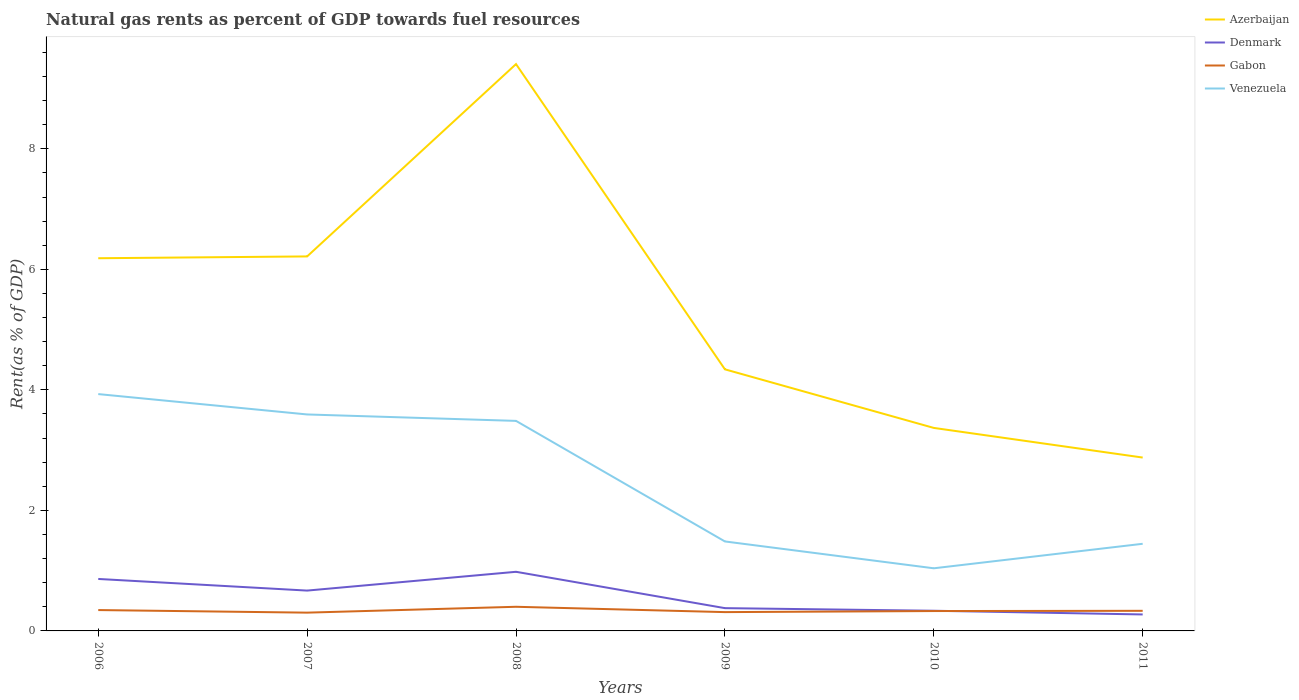How many different coloured lines are there?
Ensure brevity in your answer.  4. Is the number of lines equal to the number of legend labels?
Ensure brevity in your answer.  Yes. Across all years, what is the maximum matural gas rent in Gabon?
Provide a short and direct response. 0.3. What is the total matural gas rent in Gabon in the graph?
Provide a short and direct response. 0.02. What is the difference between the highest and the second highest matural gas rent in Venezuela?
Make the answer very short. 2.89. What is the difference between the highest and the lowest matural gas rent in Gabon?
Offer a terse response. 2. How many lines are there?
Make the answer very short. 4. What is the difference between two consecutive major ticks on the Y-axis?
Offer a very short reply. 2. Are the values on the major ticks of Y-axis written in scientific E-notation?
Ensure brevity in your answer.  No. Does the graph contain any zero values?
Ensure brevity in your answer.  No. How many legend labels are there?
Ensure brevity in your answer.  4. What is the title of the graph?
Keep it short and to the point. Natural gas rents as percent of GDP towards fuel resources. What is the label or title of the X-axis?
Provide a succinct answer. Years. What is the label or title of the Y-axis?
Your answer should be very brief. Rent(as % of GDP). What is the Rent(as % of GDP) of Azerbaijan in 2006?
Your answer should be compact. 6.18. What is the Rent(as % of GDP) of Denmark in 2006?
Your answer should be compact. 0.86. What is the Rent(as % of GDP) of Gabon in 2006?
Make the answer very short. 0.35. What is the Rent(as % of GDP) in Venezuela in 2006?
Give a very brief answer. 3.93. What is the Rent(as % of GDP) in Azerbaijan in 2007?
Offer a terse response. 6.21. What is the Rent(as % of GDP) of Denmark in 2007?
Ensure brevity in your answer.  0.67. What is the Rent(as % of GDP) of Gabon in 2007?
Your response must be concise. 0.3. What is the Rent(as % of GDP) in Venezuela in 2007?
Ensure brevity in your answer.  3.59. What is the Rent(as % of GDP) of Azerbaijan in 2008?
Offer a very short reply. 9.41. What is the Rent(as % of GDP) of Denmark in 2008?
Your answer should be very brief. 0.98. What is the Rent(as % of GDP) of Gabon in 2008?
Provide a short and direct response. 0.4. What is the Rent(as % of GDP) in Venezuela in 2008?
Provide a short and direct response. 3.49. What is the Rent(as % of GDP) in Azerbaijan in 2009?
Make the answer very short. 4.34. What is the Rent(as % of GDP) of Denmark in 2009?
Your answer should be compact. 0.38. What is the Rent(as % of GDP) of Gabon in 2009?
Make the answer very short. 0.31. What is the Rent(as % of GDP) in Venezuela in 2009?
Offer a very short reply. 1.48. What is the Rent(as % of GDP) in Azerbaijan in 2010?
Your answer should be very brief. 3.37. What is the Rent(as % of GDP) of Denmark in 2010?
Ensure brevity in your answer.  0.33. What is the Rent(as % of GDP) in Gabon in 2010?
Your answer should be very brief. 0.33. What is the Rent(as % of GDP) of Venezuela in 2010?
Offer a terse response. 1.04. What is the Rent(as % of GDP) of Azerbaijan in 2011?
Your response must be concise. 2.88. What is the Rent(as % of GDP) of Denmark in 2011?
Offer a very short reply. 0.27. What is the Rent(as % of GDP) of Gabon in 2011?
Your answer should be very brief. 0.33. What is the Rent(as % of GDP) in Venezuela in 2011?
Ensure brevity in your answer.  1.45. Across all years, what is the maximum Rent(as % of GDP) of Azerbaijan?
Your response must be concise. 9.41. Across all years, what is the maximum Rent(as % of GDP) of Denmark?
Your answer should be very brief. 0.98. Across all years, what is the maximum Rent(as % of GDP) of Gabon?
Make the answer very short. 0.4. Across all years, what is the maximum Rent(as % of GDP) in Venezuela?
Offer a terse response. 3.93. Across all years, what is the minimum Rent(as % of GDP) in Azerbaijan?
Keep it short and to the point. 2.88. Across all years, what is the minimum Rent(as % of GDP) in Denmark?
Give a very brief answer. 0.27. Across all years, what is the minimum Rent(as % of GDP) in Gabon?
Your response must be concise. 0.3. Across all years, what is the minimum Rent(as % of GDP) in Venezuela?
Offer a terse response. 1.04. What is the total Rent(as % of GDP) in Azerbaijan in the graph?
Your response must be concise. 32.39. What is the total Rent(as % of GDP) in Denmark in the graph?
Make the answer very short. 3.5. What is the total Rent(as % of GDP) of Gabon in the graph?
Offer a very short reply. 2.03. What is the total Rent(as % of GDP) in Venezuela in the graph?
Your response must be concise. 14.98. What is the difference between the Rent(as % of GDP) of Azerbaijan in 2006 and that in 2007?
Your answer should be very brief. -0.03. What is the difference between the Rent(as % of GDP) in Denmark in 2006 and that in 2007?
Provide a short and direct response. 0.19. What is the difference between the Rent(as % of GDP) of Gabon in 2006 and that in 2007?
Keep it short and to the point. 0.04. What is the difference between the Rent(as % of GDP) of Venezuela in 2006 and that in 2007?
Your answer should be compact. 0.34. What is the difference between the Rent(as % of GDP) in Azerbaijan in 2006 and that in 2008?
Give a very brief answer. -3.22. What is the difference between the Rent(as % of GDP) in Denmark in 2006 and that in 2008?
Provide a short and direct response. -0.12. What is the difference between the Rent(as % of GDP) in Gabon in 2006 and that in 2008?
Ensure brevity in your answer.  -0.05. What is the difference between the Rent(as % of GDP) of Venezuela in 2006 and that in 2008?
Make the answer very short. 0.44. What is the difference between the Rent(as % of GDP) in Azerbaijan in 2006 and that in 2009?
Provide a short and direct response. 1.84. What is the difference between the Rent(as % of GDP) in Denmark in 2006 and that in 2009?
Make the answer very short. 0.48. What is the difference between the Rent(as % of GDP) of Gabon in 2006 and that in 2009?
Your answer should be compact. 0.03. What is the difference between the Rent(as % of GDP) of Venezuela in 2006 and that in 2009?
Provide a succinct answer. 2.45. What is the difference between the Rent(as % of GDP) in Azerbaijan in 2006 and that in 2010?
Make the answer very short. 2.82. What is the difference between the Rent(as % of GDP) in Denmark in 2006 and that in 2010?
Offer a very short reply. 0.53. What is the difference between the Rent(as % of GDP) of Gabon in 2006 and that in 2010?
Your response must be concise. 0.02. What is the difference between the Rent(as % of GDP) in Venezuela in 2006 and that in 2010?
Your answer should be compact. 2.89. What is the difference between the Rent(as % of GDP) of Azerbaijan in 2006 and that in 2011?
Offer a very short reply. 3.31. What is the difference between the Rent(as % of GDP) of Denmark in 2006 and that in 2011?
Provide a succinct answer. 0.59. What is the difference between the Rent(as % of GDP) of Gabon in 2006 and that in 2011?
Your answer should be compact. 0.01. What is the difference between the Rent(as % of GDP) of Venezuela in 2006 and that in 2011?
Provide a short and direct response. 2.48. What is the difference between the Rent(as % of GDP) of Azerbaijan in 2007 and that in 2008?
Your answer should be compact. -3.19. What is the difference between the Rent(as % of GDP) in Denmark in 2007 and that in 2008?
Offer a terse response. -0.31. What is the difference between the Rent(as % of GDP) in Gabon in 2007 and that in 2008?
Provide a succinct answer. -0.1. What is the difference between the Rent(as % of GDP) in Venezuela in 2007 and that in 2008?
Provide a short and direct response. 0.11. What is the difference between the Rent(as % of GDP) of Azerbaijan in 2007 and that in 2009?
Offer a very short reply. 1.87. What is the difference between the Rent(as % of GDP) in Denmark in 2007 and that in 2009?
Your answer should be very brief. 0.29. What is the difference between the Rent(as % of GDP) of Gabon in 2007 and that in 2009?
Your answer should be compact. -0.01. What is the difference between the Rent(as % of GDP) of Venezuela in 2007 and that in 2009?
Make the answer very short. 2.11. What is the difference between the Rent(as % of GDP) of Azerbaijan in 2007 and that in 2010?
Your answer should be very brief. 2.85. What is the difference between the Rent(as % of GDP) in Denmark in 2007 and that in 2010?
Provide a short and direct response. 0.33. What is the difference between the Rent(as % of GDP) of Gabon in 2007 and that in 2010?
Offer a terse response. -0.03. What is the difference between the Rent(as % of GDP) in Venezuela in 2007 and that in 2010?
Ensure brevity in your answer.  2.55. What is the difference between the Rent(as % of GDP) in Azerbaijan in 2007 and that in 2011?
Give a very brief answer. 3.34. What is the difference between the Rent(as % of GDP) of Denmark in 2007 and that in 2011?
Offer a very short reply. 0.4. What is the difference between the Rent(as % of GDP) of Gabon in 2007 and that in 2011?
Provide a short and direct response. -0.03. What is the difference between the Rent(as % of GDP) of Venezuela in 2007 and that in 2011?
Keep it short and to the point. 2.15. What is the difference between the Rent(as % of GDP) of Azerbaijan in 2008 and that in 2009?
Make the answer very short. 5.07. What is the difference between the Rent(as % of GDP) in Denmark in 2008 and that in 2009?
Make the answer very short. 0.6. What is the difference between the Rent(as % of GDP) in Gabon in 2008 and that in 2009?
Provide a succinct answer. 0.09. What is the difference between the Rent(as % of GDP) of Venezuela in 2008 and that in 2009?
Your response must be concise. 2. What is the difference between the Rent(as % of GDP) in Azerbaijan in 2008 and that in 2010?
Keep it short and to the point. 6.04. What is the difference between the Rent(as % of GDP) of Denmark in 2008 and that in 2010?
Offer a terse response. 0.65. What is the difference between the Rent(as % of GDP) of Gabon in 2008 and that in 2010?
Your response must be concise. 0.07. What is the difference between the Rent(as % of GDP) in Venezuela in 2008 and that in 2010?
Give a very brief answer. 2.45. What is the difference between the Rent(as % of GDP) in Azerbaijan in 2008 and that in 2011?
Ensure brevity in your answer.  6.53. What is the difference between the Rent(as % of GDP) of Denmark in 2008 and that in 2011?
Your response must be concise. 0.71. What is the difference between the Rent(as % of GDP) in Gabon in 2008 and that in 2011?
Ensure brevity in your answer.  0.07. What is the difference between the Rent(as % of GDP) of Venezuela in 2008 and that in 2011?
Your answer should be very brief. 2.04. What is the difference between the Rent(as % of GDP) of Azerbaijan in 2009 and that in 2010?
Your answer should be compact. 0.97. What is the difference between the Rent(as % of GDP) in Denmark in 2009 and that in 2010?
Your answer should be very brief. 0.04. What is the difference between the Rent(as % of GDP) of Gabon in 2009 and that in 2010?
Keep it short and to the point. -0.02. What is the difference between the Rent(as % of GDP) of Venezuela in 2009 and that in 2010?
Your answer should be very brief. 0.45. What is the difference between the Rent(as % of GDP) of Azerbaijan in 2009 and that in 2011?
Your response must be concise. 1.46. What is the difference between the Rent(as % of GDP) in Denmark in 2009 and that in 2011?
Give a very brief answer. 0.1. What is the difference between the Rent(as % of GDP) of Gabon in 2009 and that in 2011?
Your answer should be compact. -0.02. What is the difference between the Rent(as % of GDP) in Venezuela in 2009 and that in 2011?
Give a very brief answer. 0.04. What is the difference between the Rent(as % of GDP) of Azerbaijan in 2010 and that in 2011?
Provide a succinct answer. 0.49. What is the difference between the Rent(as % of GDP) of Denmark in 2010 and that in 2011?
Ensure brevity in your answer.  0.06. What is the difference between the Rent(as % of GDP) of Gabon in 2010 and that in 2011?
Make the answer very short. -0. What is the difference between the Rent(as % of GDP) of Venezuela in 2010 and that in 2011?
Provide a short and direct response. -0.41. What is the difference between the Rent(as % of GDP) in Azerbaijan in 2006 and the Rent(as % of GDP) in Denmark in 2007?
Your answer should be compact. 5.51. What is the difference between the Rent(as % of GDP) of Azerbaijan in 2006 and the Rent(as % of GDP) of Gabon in 2007?
Offer a terse response. 5.88. What is the difference between the Rent(as % of GDP) of Azerbaijan in 2006 and the Rent(as % of GDP) of Venezuela in 2007?
Provide a short and direct response. 2.59. What is the difference between the Rent(as % of GDP) in Denmark in 2006 and the Rent(as % of GDP) in Gabon in 2007?
Your answer should be compact. 0.56. What is the difference between the Rent(as % of GDP) of Denmark in 2006 and the Rent(as % of GDP) of Venezuela in 2007?
Your answer should be very brief. -2.73. What is the difference between the Rent(as % of GDP) of Gabon in 2006 and the Rent(as % of GDP) of Venezuela in 2007?
Keep it short and to the point. -3.25. What is the difference between the Rent(as % of GDP) in Azerbaijan in 2006 and the Rent(as % of GDP) in Denmark in 2008?
Your answer should be compact. 5.2. What is the difference between the Rent(as % of GDP) in Azerbaijan in 2006 and the Rent(as % of GDP) in Gabon in 2008?
Give a very brief answer. 5.78. What is the difference between the Rent(as % of GDP) in Azerbaijan in 2006 and the Rent(as % of GDP) in Venezuela in 2008?
Your response must be concise. 2.7. What is the difference between the Rent(as % of GDP) in Denmark in 2006 and the Rent(as % of GDP) in Gabon in 2008?
Keep it short and to the point. 0.46. What is the difference between the Rent(as % of GDP) of Denmark in 2006 and the Rent(as % of GDP) of Venezuela in 2008?
Keep it short and to the point. -2.62. What is the difference between the Rent(as % of GDP) in Gabon in 2006 and the Rent(as % of GDP) in Venezuela in 2008?
Make the answer very short. -3.14. What is the difference between the Rent(as % of GDP) of Azerbaijan in 2006 and the Rent(as % of GDP) of Denmark in 2009?
Offer a very short reply. 5.81. What is the difference between the Rent(as % of GDP) of Azerbaijan in 2006 and the Rent(as % of GDP) of Gabon in 2009?
Provide a short and direct response. 5.87. What is the difference between the Rent(as % of GDP) of Azerbaijan in 2006 and the Rent(as % of GDP) of Venezuela in 2009?
Provide a succinct answer. 4.7. What is the difference between the Rent(as % of GDP) of Denmark in 2006 and the Rent(as % of GDP) of Gabon in 2009?
Keep it short and to the point. 0.55. What is the difference between the Rent(as % of GDP) of Denmark in 2006 and the Rent(as % of GDP) of Venezuela in 2009?
Provide a succinct answer. -0.62. What is the difference between the Rent(as % of GDP) of Gabon in 2006 and the Rent(as % of GDP) of Venezuela in 2009?
Give a very brief answer. -1.14. What is the difference between the Rent(as % of GDP) in Azerbaijan in 2006 and the Rent(as % of GDP) in Denmark in 2010?
Give a very brief answer. 5.85. What is the difference between the Rent(as % of GDP) in Azerbaijan in 2006 and the Rent(as % of GDP) in Gabon in 2010?
Make the answer very short. 5.85. What is the difference between the Rent(as % of GDP) of Azerbaijan in 2006 and the Rent(as % of GDP) of Venezuela in 2010?
Provide a short and direct response. 5.14. What is the difference between the Rent(as % of GDP) in Denmark in 2006 and the Rent(as % of GDP) in Gabon in 2010?
Give a very brief answer. 0.53. What is the difference between the Rent(as % of GDP) in Denmark in 2006 and the Rent(as % of GDP) in Venezuela in 2010?
Keep it short and to the point. -0.18. What is the difference between the Rent(as % of GDP) in Gabon in 2006 and the Rent(as % of GDP) in Venezuela in 2010?
Offer a very short reply. -0.69. What is the difference between the Rent(as % of GDP) in Azerbaijan in 2006 and the Rent(as % of GDP) in Denmark in 2011?
Your response must be concise. 5.91. What is the difference between the Rent(as % of GDP) in Azerbaijan in 2006 and the Rent(as % of GDP) in Gabon in 2011?
Give a very brief answer. 5.85. What is the difference between the Rent(as % of GDP) of Azerbaijan in 2006 and the Rent(as % of GDP) of Venezuela in 2011?
Offer a very short reply. 4.74. What is the difference between the Rent(as % of GDP) in Denmark in 2006 and the Rent(as % of GDP) in Gabon in 2011?
Make the answer very short. 0.53. What is the difference between the Rent(as % of GDP) of Denmark in 2006 and the Rent(as % of GDP) of Venezuela in 2011?
Keep it short and to the point. -0.58. What is the difference between the Rent(as % of GDP) in Gabon in 2006 and the Rent(as % of GDP) in Venezuela in 2011?
Offer a very short reply. -1.1. What is the difference between the Rent(as % of GDP) in Azerbaijan in 2007 and the Rent(as % of GDP) in Denmark in 2008?
Your answer should be very brief. 5.23. What is the difference between the Rent(as % of GDP) of Azerbaijan in 2007 and the Rent(as % of GDP) of Gabon in 2008?
Provide a short and direct response. 5.81. What is the difference between the Rent(as % of GDP) in Azerbaijan in 2007 and the Rent(as % of GDP) in Venezuela in 2008?
Offer a terse response. 2.73. What is the difference between the Rent(as % of GDP) in Denmark in 2007 and the Rent(as % of GDP) in Gabon in 2008?
Make the answer very short. 0.27. What is the difference between the Rent(as % of GDP) of Denmark in 2007 and the Rent(as % of GDP) of Venezuela in 2008?
Provide a succinct answer. -2.82. What is the difference between the Rent(as % of GDP) of Gabon in 2007 and the Rent(as % of GDP) of Venezuela in 2008?
Your answer should be very brief. -3.18. What is the difference between the Rent(as % of GDP) in Azerbaijan in 2007 and the Rent(as % of GDP) in Denmark in 2009?
Provide a short and direct response. 5.84. What is the difference between the Rent(as % of GDP) of Azerbaijan in 2007 and the Rent(as % of GDP) of Gabon in 2009?
Provide a succinct answer. 5.9. What is the difference between the Rent(as % of GDP) in Azerbaijan in 2007 and the Rent(as % of GDP) in Venezuela in 2009?
Offer a very short reply. 4.73. What is the difference between the Rent(as % of GDP) in Denmark in 2007 and the Rent(as % of GDP) in Gabon in 2009?
Offer a very short reply. 0.36. What is the difference between the Rent(as % of GDP) in Denmark in 2007 and the Rent(as % of GDP) in Venezuela in 2009?
Your response must be concise. -0.82. What is the difference between the Rent(as % of GDP) in Gabon in 2007 and the Rent(as % of GDP) in Venezuela in 2009?
Your answer should be very brief. -1.18. What is the difference between the Rent(as % of GDP) of Azerbaijan in 2007 and the Rent(as % of GDP) of Denmark in 2010?
Provide a succinct answer. 5.88. What is the difference between the Rent(as % of GDP) in Azerbaijan in 2007 and the Rent(as % of GDP) in Gabon in 2010?
Make the answer very short. 5.88. What is the difference between the Rent(as % of GDP) of Azerbaijan in 2007 and the Rent(as % of GDP) of Venezuela in 2010?
Your answer should be compact. 5.17. What is the difference between the Rent(as % of GDP) in Denmark in 2007 and the Rent(as % of GDP) in Gabon in 2010?
Ensure brevity in your answer.  0.34. What is the difference between the Rent(as % of GDP) of Denmark in 2007 and the Rent(as % of GDP) of Venezuela in 2010?
Make the answer very short. -0.37. What is the difference between the Rent(as % of GDP) in Gabon in 2007 and the Rent(as % of GDP) in Venezuela in 2010?
Give a very brief answer. -0.74. What is the difference between the Rent(as % of GDP) in Azerbaijan in 2007 and the Rent(as % of GDP) in Denmark in 2011?
Your answer should be very brief. 5.94. What is the difference between the Rent(as % of GDP) in Azerbaijan in 2007 and the Rent(as % of GDP) in Gabon in 2011?
Give a very brief answer. 5.88. What is the difference between the Rent(as % of GDP) of Azerbaijan in 2007 and the Rent(as % of GDP) of Venezuela in 2011?
Your answer should be compact. 4.77. What is the difference between the Rent(as % of GDP) in Denmark in 2007 and the Rent(as % of GDP) in Gabon in 2011?
Give a very brief answer. 0.34. What is the difference between the Rent(as % of GDP) in Denmark in 2007 and the Rent(as % of GDP) in Venezuela in 2011?
Provide a short and direct response. -0.78. What is the difference between the Rent(as % of GDP) in Gabon in 2007 and the Rent(as % of GDP) in Venezuela in 2011?
Provide a succinct answer. -1.14. What is the difference between the Rent(as % of GDP) of Azerbaijan in 2008 and the Rent(as % of GDP) of Denmark in 2009?
Provide a succinct answer. 9.03. What is the difference between the Rent(as % of GDP) of Azerbaijan in 2008 and the Rent(as % of GDP) of Gabon in 2009?
Ensure brevity in your answer.  9.09. What is the difference between the Rent(as % of GDP) of Azerbaijan in 2008 and the Rent(as % of GDP) of Venezuela in 2009?
Your response must be concise. 7.92. What is the difference between the Rent(as % of GDP) in Denmark in 2008 and the Rent(as % of GDP) in Gabon in 2009?
Your response must be concise. 0.67. What is the difference between the Rent(as % of GDP) in Denmark in 2008 and the Rent(as % of GDP) in Venezuela in 2009?
Your response must be concise. -0.5. What is the difference between the Rent(as % of GDP) in Gabon in 2008 and the Rent(as % of GDP) in Venezuela in 2009?
Your answer should be compact. -1.08. What is the difference between the Rent(as % of GDP) of Azerbaijan in 2008 and the Rent(as % of GDP) of Denmark in 2010?
Make the answer very short. 9.07. What is the difference between the Rent(as % of GDP) in Azerbaijan in 2008 and the Rent(as % of GDP) in Gabon in 2010?
Provide a succinct answer. 9.08. What is the difference between the Rent(as % of GDP) of Azerbaijan in 2008 and the Rent(as % of GDP) of Venezuela in 2010?
Give a very brief answer. 8.37. What is the difference between the Rent(as % of GDP) in Denmark in 2008 and the Rent(as % of GDP) in Gabon in 2010?
Your answer should be very brief. 0.65. What is the difference between the Rent(as % of GDP) of Denmark in 2008 and the Rent(as % of GDP) of Venezuela in 2010?
Offer a very short reply. -0.06. What is the difference between the Rent(as % of GDP) of Gabon in 2008 and the Rent(as % of GDP) of Venezuela in 2010?
Your answer should be very brief. -0.64. What is the difference between the Rent(as % of GDP) of Azerbaijan in 2008 and the Rent(as % of GDP) of Denmark in 2011?
Offer a very short reply. 9.13. What is the difference between the Rent(as % of GDP) of Azerbaijan in 2008 and the Rent(as % of GDP) of Gabon in 2011?
Provide a succinct answer. 9.07. What is the difference between the Rent(as % of GDP) in Azerbaijan in 2008 and the Rent(as % of GDP) in Venezuela in 2011?
Ensure brevity in your answer.  7.96. What is the difference between the Rent(as % of GDP) in Denmark in 2008 and the Rent(as % of GDP) in Gabon in 2011?
Keep it short and to the point. 0.65. What is the difference between the Rent(as % of GDP) in Denmark in 2008 and the Rent(as % of GDP) in Venezuela in 2011?
Keep it short and to the point. -0.46. What is the difference between the Rent(as % of GDP) in Gabon in 2008 and the Rent(as % of GDP) in Venezuela in 2011?
Give a very brief answer. -1.05. What is the difference between the Rent(as % of GDP) of Azerbaijan in 2009 and the Rent(as % of GDP) of Denmark in 2010?
Offer a terse response. 4.01. What is the difference between the Rent(as % of GDP) in Azerbaijan in 2009 and the Rent(as % of GDP) in Gabon in 2010?
Offer a terse response. 4.01. What is the difference between the Rent(as % of GDP) of Azerbaijan in 2009 and the Rent(as % of GDP) of Venezuela in 2010?
Provide a succinct answer. 3.3. What is the difference between the Rent(as % of GDP) of Denmark in 2009 and the Rent(as % of GDP) of Gabon in 2010?
Make the answer very short. 0.05. What is the difference between the Rent(as % of GDP) in Denmark in 2009 and the Rent(as % of GDP) in Venezuela in 2010?
Ensure brevity in your answer.  -0.66. What is the difference between the Rent(as % of GDP) in Gabon in 2009 and the Rent(as % of GDP) in Venezuela in 2010?
Your answer should be compact. -0.73. What is the difference between the Rent(as % of GDP) of Azerbaijan in 2009 and the Rent(as % of GDP) of Denmark in 2011?
Ensure brevity in your answer.  4.07. What is the difference between the Rent(as % of GDP) in Azerbaijan in 2009 and the Rent(as % of GDP) in Gabon in 2011?
Offer a very short reply. 4.01. What is the difference between the Rent(as % of GDP) in Azerbaijan in 2009 and the Rent(as % of GDP) in Venezuela in 2011?
Offer a terse response. 2.9. What is the difference between the Rent(as % of GDP) of Denmark in 2009 and the Rent(as % of GDP) of Gabon in 2011?
Your answer should be compact. 0.04. What is the difference between the Rent(as % of GDP) of Denmark in 2009 and the Rent(as % of GDP) of Venezuela in 2011?
Keep it short and to the point. -1.07. What is the difference between the Rent(as % of GDP) of Gabon in 2009 and the Rent(as % of GDP) of Venezuela in 2011?
Make the answer very short. -1.13. What is the difference between the Rent(as % of GDP) of Azerbaijan in 2010 and the Rent(as % of GDP) of Denmark in 2011?
Give a very brief answer. 3.1. What is the difference between the Rent(as % of GDP) of Azerbaijan in 2010 and the Rent(as % of GDP) of Gabon in 2011?
Offer a very short reply. 3.03. What is the difference between the Rent(as % of GDP) of Azerbaijan in 2010 and the Rent(as % of GDP) of Venezuela in 2011?
Provide a succinct answer. 1.92. What is the difference between the Rent(as % of GDP) in Denmark in 2010 and the Rent(as % of GDP) in Venezuela in 2011?
Your answer should be very brief. -1.11. What is the difference between the Rent(as % of GDP) of Gabon in 2010 and the Rent(as % of GDP) of Venezuela in 2011?
Offer a terse response. -1.12. What is the average Rent(as % of GDP) of Azerbaijan per year?
Your response must be concise. 5.4. What is the average Rent(as % of GDP) of Denmark per year?
Your response must be concise. 0.58. What is the average Rent(as % of GDP) of Gabon per year?
Your response must be concise. 0.34. What is the average Rent(as % of GDP) in Venezuela per year?
Your response must be concise. 2.5. In the year 2006, what is the difference between the Rent(as % of GDP) in Azerbaijan and Rent(as % of GDP) in Denmark?
Offer a terse response. 5.32. In the year 2006, what is the difference between the Rent(as % of GDP) in Azerbaijan and Rent(as % of GDP) in Gabon?
Give a very brief answer. 5.84. In the year 2006, what is the difference between the Rent(as % of GDP) in Azerbaijan and Rent(as % of GDP) in Venezuela?
Give a very brief answer. 2.25. In the year 2006, what is the difference between the Rent(as % of GDP) of Denmark and Rent(as % of GDP) of Gabon?
Give a very brief answer. 0.52. In the year 2006, what is the difference between the Rent(as % of GDP) in Denmark and Rent(as % of GDP) in Venezuela?
Offer a terse response. -3.07. In the year 2006, what is the difference between the Rent(as % of GDP) in Gabon and Rent(as % of GDP) in Venezuela?
Offer a very short reply. -3.58. In the year 2007, what is the difference between the Rent(as % of GDP) in Azerbaijan and Rent(as % of GDP) in Denmark?
Give a very brief answer. 5.55. In the year 2007, what is the difference between the Rent(as % of GDP) of Azerbaijan and Rent(as % of GDP) of Gabon?
Provide a succinct answer. 5.91. In the year 2007, what is the difference between the Rent(as % of GDP) in Azerbaijan and Rent(as % of GDP) in Venezuela?
Your response must be concise. 2.62. In the year 2007, what is the difference between the Rent(as % of GDP) of Denmark and Rent(as % of GDP) of Gabon?
Provide a short and direct response. 0.37. In the year 2007, what is the difference between the Rent(as % of GDP) of Denmark and Rent(as % of GDP) of Venezuela?
Your answer should be very brief. -2.92. In the year 2007, what is the difference between the Rent(as % of GDP) in Gabon and Rent(as % of GDP) in Venezuela?
Your response must be concise. -3.29. In the year 2008, what is the difference between the Rent(as % of GDP) of Azerbaijan and Rent(as % of GDP) of Denmark?
Your answer should be compact. 8.42. In the year 2008, what is the difference between the Rent(as % of GDP) in Azerbaijan and Rent(as % of GDP) in Gabon?
Your response must be concise. 9.01. In the year 2008, what is the difference between the Rent(as % of GDP) in Azerbaijan and Rent(as % of GDP) in Venezuela?
Provide a short and direct response. 5.92. In the year 2008, what is the difference between the Rent(as % of GDP) in Denmark and Rent(as % of GDP) in Gabon?
Provide a succinct answer. 0.58. In the year 2008, what is the difference between the Rent(as % of GDP) in Denmark and Rent(as % of GDP) in Venezuela?
Give a very brief answer. -2.5. In the year 2008, what is the difference between the Rent(as % of GDP) in Gabon and Rent(as % of GDP) in Venezuela?
Provide a succinct answer. -3.08. In the year 2009, what is the difference between the Rent(as % of GDP) of Azerbaijan and Rent(as % of GDP) of Denmark?
Your answer should be very brief. 3.96. In the year 2009, what is the difference between the Rent(as % of GDP) of Azerbaijan and Rent(as % of GDP) of Gabon?
Ensure brevity in your answer.  4.03. In the year 2009, what is the difference between the Rent(as % of GDP) of Azerbaijan and Rent(as % of GDP) of Venezuela?
Provide a short and direct response. 2.86. In the year 2009, what is the difference between the Rent(as % of GDP) of Denmark and Rent(as % of GDP) of Gabon?
Provide a short and direct response. 0.07. In the year 2009, what is the difference between the Rent(as % of GDP) in Denmark and Rent(as % of GDP) in Venezuela?
Your response must be concise. -1.11. In the year 2009, what is the difference between the Rent(as % of GDP) of Gabon and Rent(as % of GDP) of Venezuela?
Your answer should be very brief. -1.17. In the year 2010, what is the difference between the Rent(as % of GDP) of Azerbaijan and Rent(as % of GDP) of Denmark?
Keep it short and to the point. 3.03. In the year 2010, what is the difference between the Rent(as % of GDP) of Azerbaijan and Rent(as % of GDP) of Gabon?
Offer a terse response. 3.04. In the year 2010, what is the difference between the Rent(as % of GDP) of Azerbaijan and Rent(as % of GDP) of Venezuela?
Offer a very short reply. 2.33. In the year 2010, what is the difference between the Rent(as % of GDP) in Denmark and Rent(as % of GDP) in Gabon?
Your response must be concise. 0.01. In the year 2010, what is the difference between the Rent(as % of GDP) of Denmark and Rent(as % of GDP) of Venezuela?
Your answer should be very brief. -0.7. In the year 2010, what is the difference between the Rent(as % of GDP) in Gabon and Rent(as % of GDP) in Venezuela?
Offer a terse response. -0.71. In the year 2011, what is the difference between the Rent(as % of GDP) in Azerbaijan and Rent(as % of GDP) in Denmark?
Keep it short and to the point. 2.6. In the year 2011, what is the difference between the Rent(as % of GDP) in Azerbaijan and Rent(as % of GDP) in Gabon?
Offer a terse response. 2.54. In the year 2011, what is the difference between the Rent(as % of GDP) in Azerbaijan and Rent(as % of GDP) in Venezuela?
Offer a terse response. 1.43. In the year 2011, what is the difference between the Rent(as % of GDP) in Denmark and Rent(as % of GDP) in Gabon?
Provide a succinct answer. -0.06. In the year 2011, what is the difference between the Rent(as % of GDP) of Denmark and Rent(as % of GDP) of Venezuela?
Offer a terse response. -1.17. In the year 2011, what is the difference between the Rent(as % of GDP) of Gabon and Rent(as % of GDP) of Venezuela?
Keep it short and to the point. -1.11. What is the ratio of the Rent(as % of GDP) in Azerbaijan in 2006 to that in 2007?
Offer a very short reply. 1. What is the ratio of the Rent(as % of GDP) in Denmark in 2006 to that in 2007?
Offer a terse response. 1.29. What is the ratio of the Rent(as % of GDP) of Gabon in 2006 to that in 2007?
Your answer should be compact. 1.14. What is the ratio of the Rent(as % of GDP) in Venezuela in 2006 to that in 2007?
Ensure brevity in your answer.  1.09. What is the ratio of the Rent(as % of GDP) in Azerbaijan in 2006 to that in 2008?
Offer a terse response. 0.66. What is the ratio of the Rent(as % of GDP) in Denmark in 2006 to that in 2008?
Keep it short and to the point. 0.88. What is the ratio of the Rent(as % of GDP) of Gabon in 2006 to that in 2008?
Your answer should be very brief. 0.86. What is the ratio of the Rent(as % of GDP) in Venezuela in 2006 to that in 2008?
Your response must be concise. 1.13. What is the ratio of the Rent(as % of GDP) in Azerbaijan in 2006 to that in 2009?
Your response must be concise. 1.42. What is the ratio of the Rent(as % of GDP) in Denmark in 2006 to that in 2009?
Give a very brief answer. 2.28. What is the ratio of the Rent(as % of GDP) in Gabon in 2006 to that in 2009?
Make the answer very short. 1.11. What is the ratio of the Rent(as % of GDP) of Venezuela in 2006 to that in 2009?
Your response must be concise. 2.65. What is the ratio of the Rent(as % of GDP) in Azerbaijan in 2006 to that in 2010?
Ensure brevity in your answer.  1.84. What is the ratio of the Rent(as % of GDP) in Denmark in 2006 to that in 2010?
Offer a terse response. 2.58. What is the ratio of the Rent(as % of GDP) of Gabon in 2006 to that in 2010?
Provide a succinct answer. 1.05. What is the ratio of the Rent(as % of GDP) of Venezuela in 2006 to that in 2010?
Offer a terse response. 3.78. What is the ratio of the Rent(as % of GDP) in Azerbaijan in 2006 to that in 2011?
Offer a very short reply. 2.15. What is the ratio of the Rent(as % of GDP) in Denmark in 2006 to that in 2011?
Give a very brief answer. 3.16. What is the ratio of the Rent(as % of GDP) in Gabon in 2006 to that in 2011?
Keep it short and to the point. 1.04. What is the ratio of the Rent(as % of GDP) in Venezuela in 2006 to that in 2011?
Ensure brevity in your answer.  2.72. What is the ratio of the Rent(as % of GDP) in Azerbaijan in 2007 to that in 2008?
Your response must be concise. 0.66. What is the ratio of the Rent(as % of GDP) in Denmark in 2007 to that in 2008?
Provide a short and direct response. 0.68. What is the ratio of the Rent(as % of GDP) of Gabon in 2007 to that in 2008?
Offer a very short reply. 0.76. What is the ratio of the Rent(as % of GDP) of Venezuela in 2007 to that in 2008?
Your response must be concise. 1.03. What is the ratio of the Rent(as % of GDP) of Azerbaijan in 2007 to that in 2009?
Your answer should be very brief. 1.43. What is the ratio of the Rent(as % of GDP) in Denmark in 2007 to that in 2009?
Your answer should be very brief. 1.77. What is the ratio of the Rent(as % of GDP) in Gabon in 2007 to that in 2009?
Offer a terse response. 0.97. What is the ratio of the Rent(as % of GDP) of Venezuela in 2007 to that in 2009?
Ensure brevity in your answer.  2.42. What is the ratio of the Rent(as % of GDP) of Azerbaijan in 2007 to that in 2010?
Your answer should be compact. 1.84. What is the ratio of the Rent(as % of GDP) of Denmark in 2007 to that in 2010?
Keep it short and to the point. 2. What is the ratio of the Rent(as % of GDP) of Gabon in 2007 to that in 2010?
Provide a succinct answer. 0.92. What is the ratio of the Rent(as % of GDP) of Venezuela in 2007 to that in 2010?
Make the answer very short. 3.46. What is the ratio of the Rent(as % of GDP) of Azerbaijan in 2007 to that in 2011?
Ensure brevity in your answer.  2.16. What is the ratio of the Rent(as % of GDP) of Denmark in 2007 to that in 2011?
Make the answer very short. 2.45. What is the ratio of the Rent(as % of GDP) in Gabon in 2007 to that in 2011?
Make the answer very short. 0.91. What is the ratio of the Rent(as % of GDP) of Venezuela in 2007 to that in 2011?
Give a very brief answer. 2.48. What is the ratio of the Rent(as % of GDP) of Azerbaijan in 2008 to that in 2009?
Provide a short and direct response. 2.17. What is the ratio of the Rent(as % of GDP) of Denmark in 2008 to that in 2009?
Make the answer very short. 2.6. What is the ratio of the Rent(as % of GDP) of Gabon in 2008 to that in 2009?
Give a very brief answer. 1.28. What is the ratio of the Rent(as % of GDP) in Venezuela in 2008 to that in 2009?
Your answer should be very brief. 2.35. What is the ratio of the Rent(as % of GDP) of Azerbaijan in 2008 to that in 2010?
Ensure brevity in your answer.  2.79. What is the ratio of the Rent(as % of GDP) of Denmark in 2008 to that in 2010?
Make the answer very short. 2.93. What is the ratio of the Rent(as % of GDP) of Gabon in 2008 to that in 2010?
Give a very brief answer. 1.21. What is the ratio of the Rent(as % of GDP) in Venezuela in 2008 to that in 2010?
Ensure brevity in your answer.  3.35. What is the ratio of the Rent(as % of GDP) of Azerbaijan in 2008 to that in 2011?
Make the answer very short. 3.27. What is the ratio of the Rent(as % of GDP) in Denmark in 2008 to that in 2011?
Provide a succinct answer. 3.59. What is the ratio of the Rent(as % of GDP) in Venezuela in 2008 to that in 2011?
Keep it short and to the point. 2.41. What is the ratio of the Rent(as % of GDP) of Azerbaijan in 2009 to that in 2010?
Offer a very short reply. 1.29. What is the ratio of the Rent(as % of GDP) of Denmark in 2009 to that in 2010?
Give a very brief answer. 1.13. What is the ratio of the Rent(as % of GDP) of Gabon in 2009 to that in 2010?
Make the answer very short. 0.95. What is the ratio of the Rent(as % of GDP) of Venezuela in 2009 to that in 2010?
Keep it short and to the point. 1.43. What is the ratio of the Rent(as % of GDP) of Azerbaijan in 2009 to that in 2011?
Your answer should be very brief. 1.51. What is the ratio of the Rent(as % of GDP) in Denmark in 2009 to that in 2011?
Your answer should be very brief. 1.38. What is the ratio of the Rent(as % of GDP) of Gabon in 2009 to that in 2011?
Ensure brevity in your answer.  0.94. What is the ratio of the Rent(as % of GDP) of Venezuela in 2009 to that in 2011?
Ensure brevity in your answer.  1.03. What is the ratio of the Rent(as % of GDP) of Azerbaijan in 2010 to that in 2011?
Ensure brevity in your answer.  1.17. What is the ratio of the Rent(as % of GDP) in Denmark in 2010 to that in 2011?
Provide a succinct answer. 1.23. What is the ratio of the Rent(as % of GDP) of Gabon in 2010 to that in 2011?
Provide a succinct answer. 0.99. What is the ratio of the Rent(as % of GDP) of Venezuela in 2010 to that in 2011?
Provide a succinct answer. 0.72. What is the difference between the highest and the second highest Rent(as % of GDP) of Azerbaijan?
Your answer should be compact. 3.19. What is the difference between the highest and the second highest Rent(as % of GDP) of Denmark?
Keep it short and to the point. 0.12. What is the difference between the highest and the second highest Rent(as % of GDP) in Gabon?
Ensure brevity in your answer.  0.05. What is the difference between the highest and the second highest Rent(as % of GDP) of Venezuela?
Make the answer very short. 0.34. What is the difference between the highest and the lowest Rent(as % of GDP) in Azerbaijan?
Your answer should be compact. 6.53. What is the difference between the highest and the lowest Rent(as % of GDP) of Denmark?
Give a very brief answer. 0.71. What is the difference between the highest and the lowest Rent(as % of GDP) of Gabon?
Offer a terse response. 0.1. What is the difference between the highest and the lowest Rent(as % of GDP) in Venezuela?
Your answer should be very brief. 2.89. 